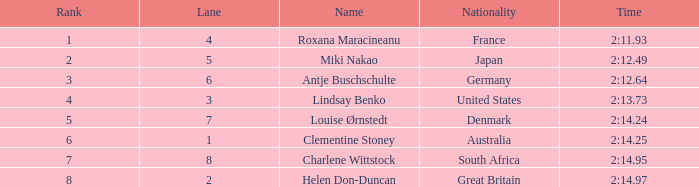What is the number of lane with a rank more than 2 for louise ørnstedt? 1.0. 